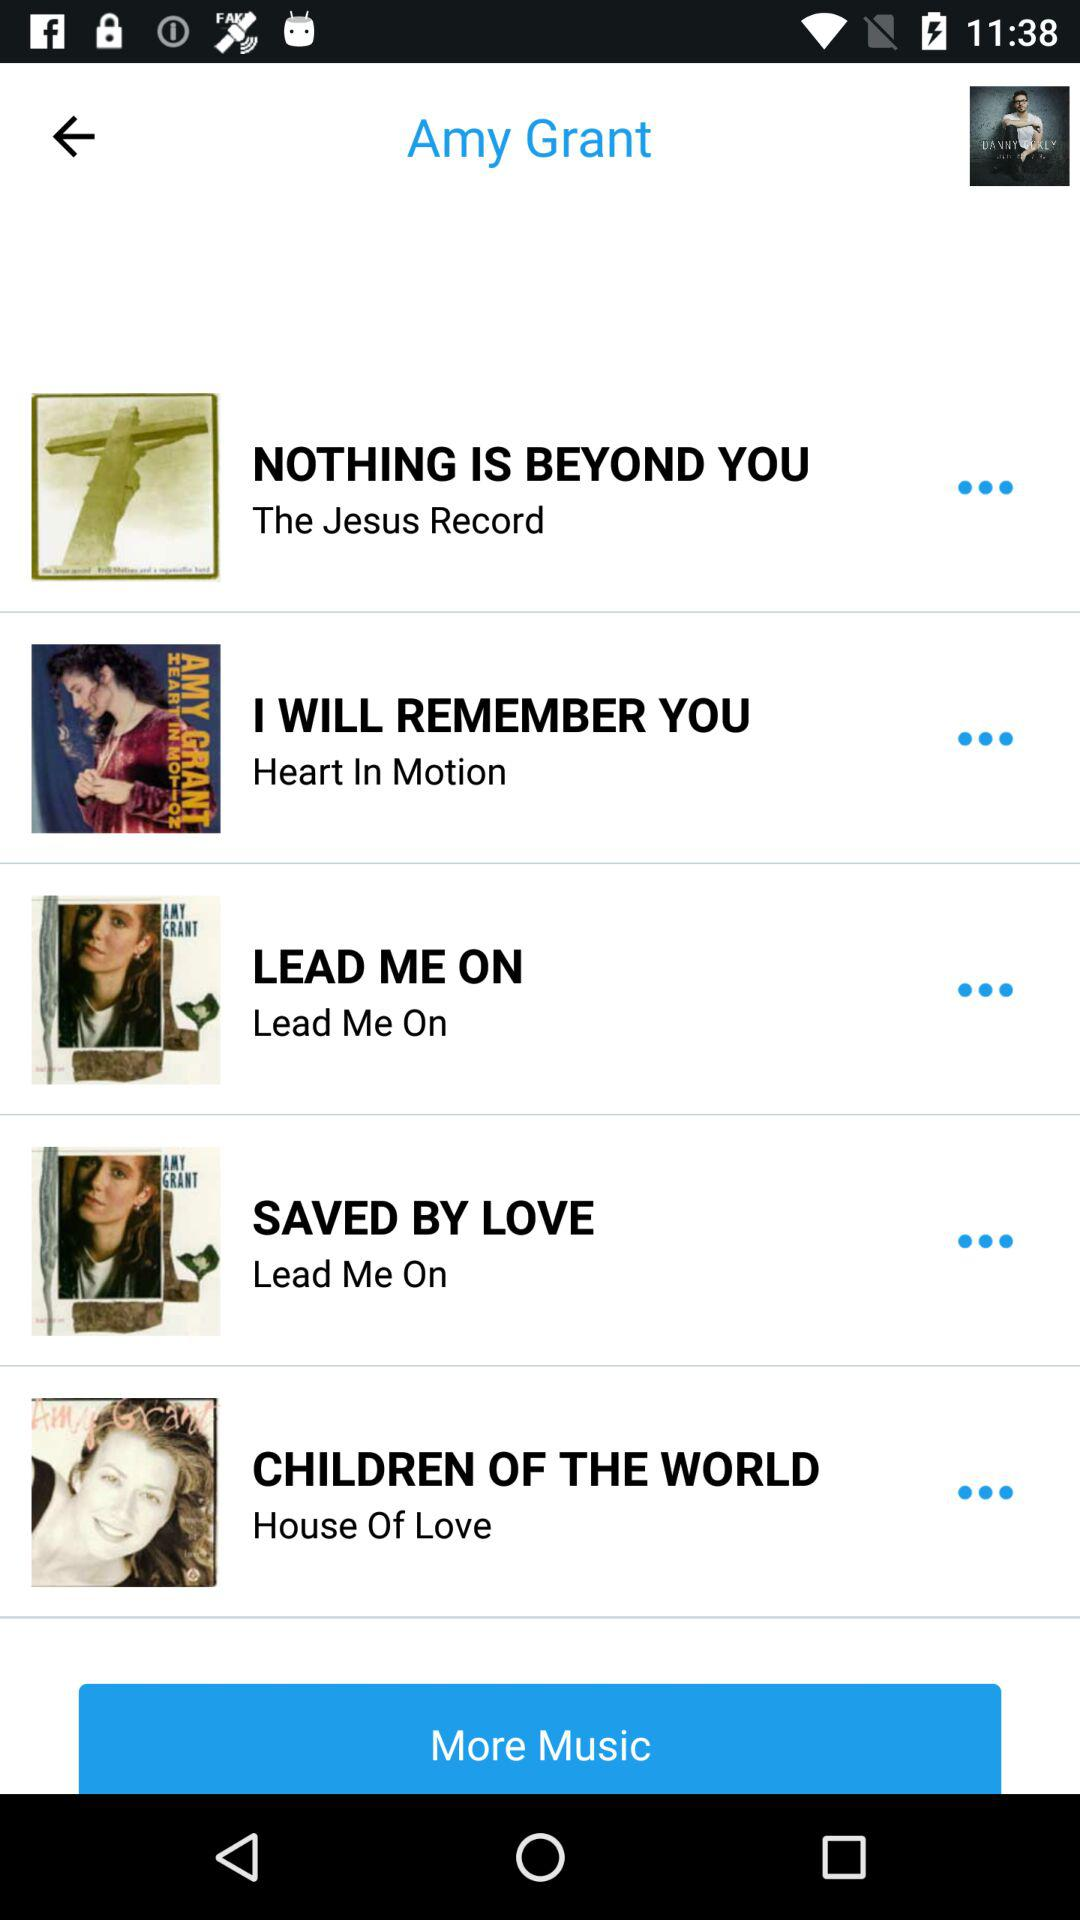"NOTHING IS BEYOND YOU" belongs to which album? It belongs to "The Jesus Record" album. 